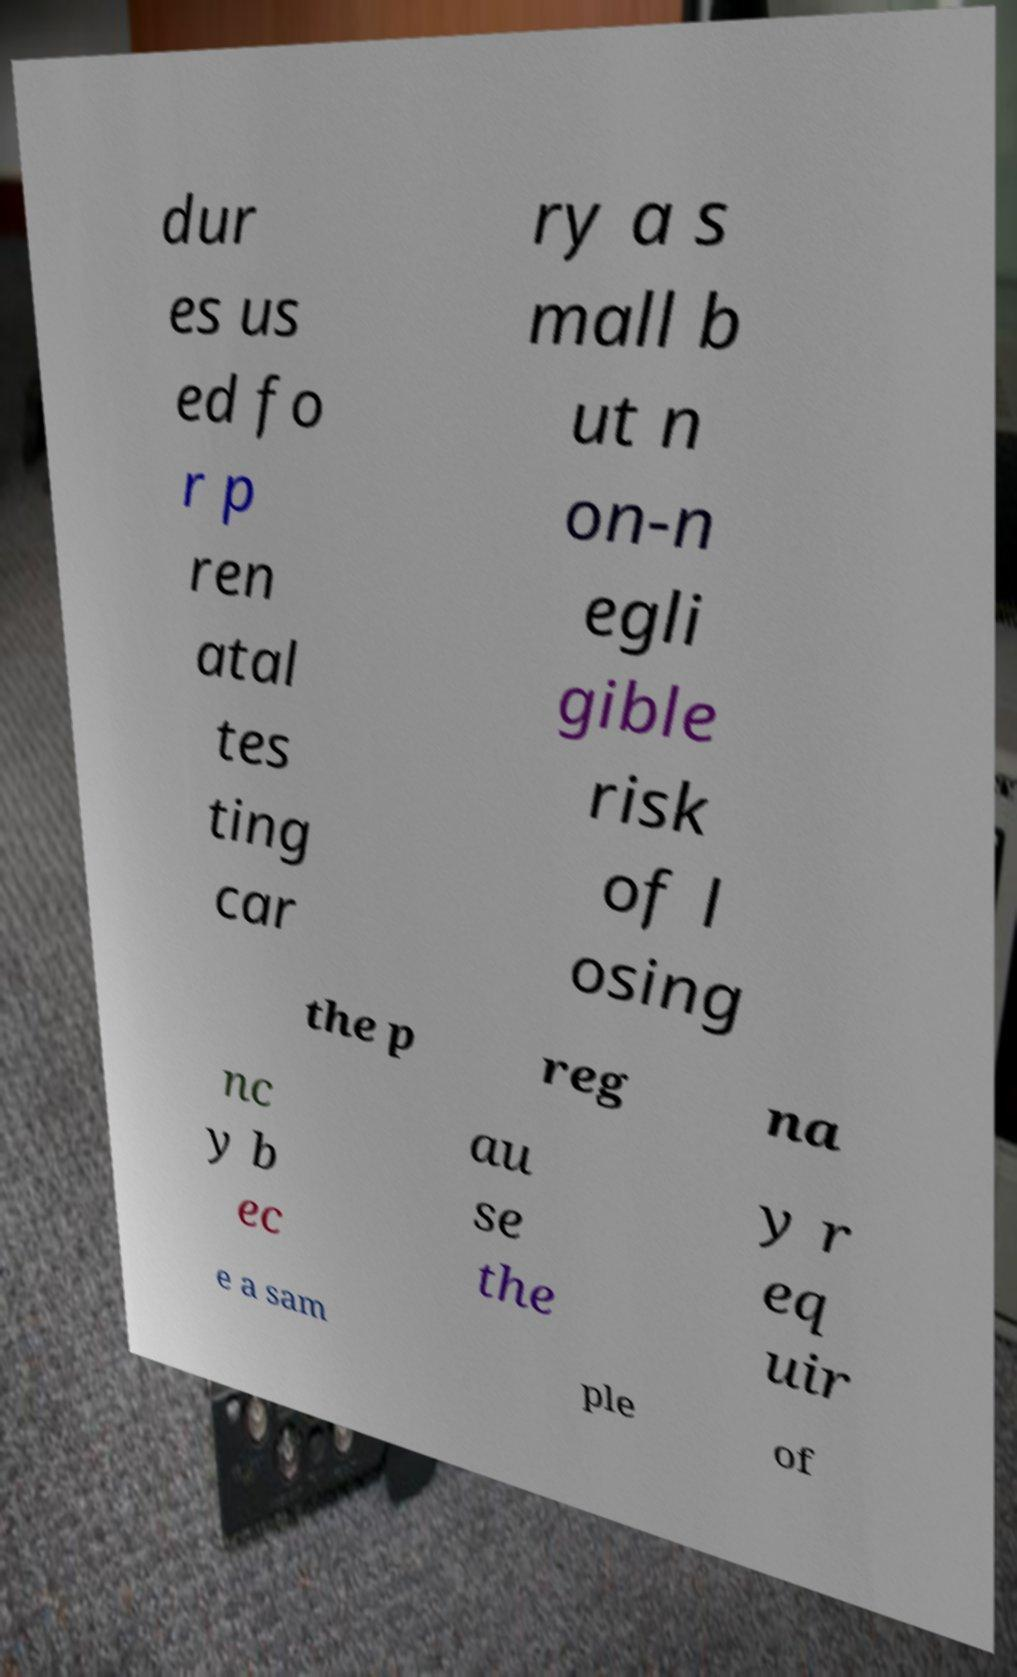Can you read and provide the text displayed in the image?This photo seems to have some interesting text. Can you extract and type it out for me? dur es us ed fo r p ren atal tes ting car ry a s mall b ut n on-n egli gible risk of l osing the p reg na nc y b ec au se the y r eq uir e a sam ple of 